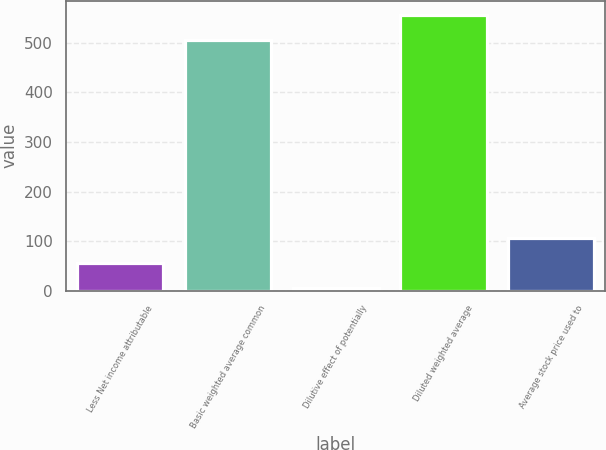Convert chart. <chart><loc_0><loc_0><loc_500><loc_500><bar_chart><fcel>Less Net income attributable<fcel>Basic weighted average common<fcel>Dilutive effect of potentially<fcel>Diluted weighted average<fcel>Average stock price used to<nl><fcel>55.6<fcel>506<fcel>5<fcel>556.6<fcel>106.2<nl></chart> 